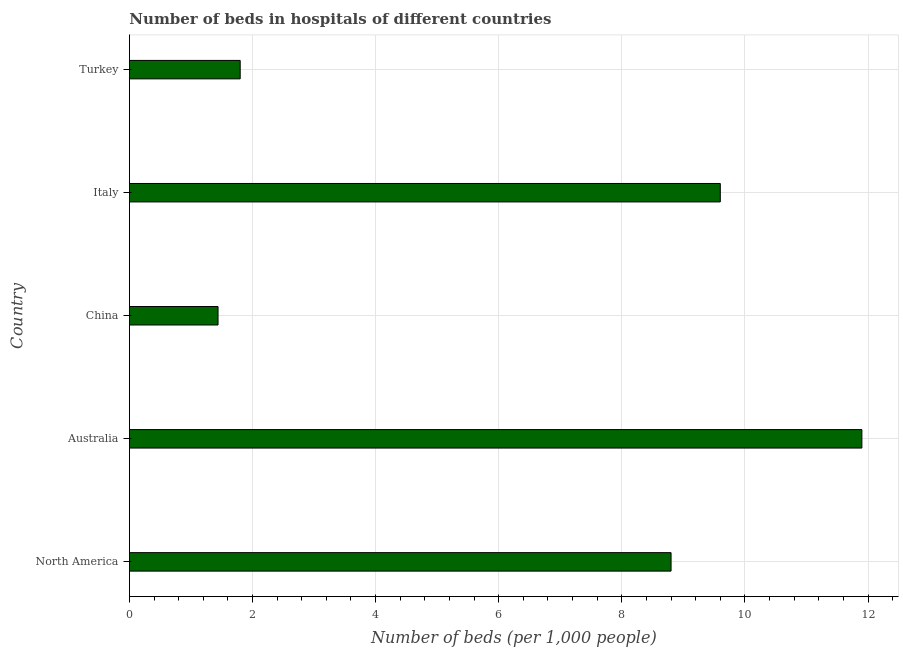Does the graph contain any zero values?
Provide a succinct answer. No. Does the graph contain grids?
Ensure brevity in your answer.  Yes. What is the title of the graph?
Your response must be concise. Number of beds in hospitals of different countries. What is the label or title of the X-axis?
Your answer should be compact. Number of beds (per 1,0 people). What is the number of hospital beds in Australia?
Offer a terse response. 11.9. Across all countries, what is the maximum number of hospital beds?
Offer a terse response. 11.9. Across all countries, what is the minimum number of hospital beds?
Ensure brevity in your answer.  1.44. What is the sum of the number of hospital beds?
Your response must be concise. 33.54. What is the difference between the number of hospital beds in China and North America?
Provide a succinct answer. -7.36. What is the average number of hospital beds per country?
Provide a short and direct response. 6.71. What is the median number of hospital beds?
Ensure brevity in your answer.  8.8. In how many countries, is the number of hospital beds greater than 6 %?
Give a very brief answer. 3. What is the ratio of the number of hospital beds in Italy to that in North America?
Keep it short and to the point. 1.09. Is the number of hospital beds in Italy less than that in Turkey?
Make the answer very short. No. What is the difference between the highest and the second highest number of hospital beds?
Ensure brevity in your answer.  2.3. What is the difference between the highest and the lowest number of hospital beds?
Your answer should be compact. 10.46. Are all the bars in the graph horizontal?
Your answer should be very brief. Yes. What is the difference between two consecutive major ticks on the X-axis?
Your response must be concise. 2. Are the values on the major ticks of X-axis written in scientific E-notation?
Offer a very short reply. No. What is the Number of beds (per 1,000 people) of North America?
Offer a very short reply. 8.8. What is the Number of beds (per 1,000 people) in Australia?
Give a very brief answer. 11.9. What is the Number of beds (per 1,000 people) of China?
Provide a short and direct response. 1.44. What is the Number of beds (per 1,000 people) in Italy?
Provide a succinct answer. 9.6. What is the Number of beds (per 1,000 people) of Turkey?
Provide a succinct answer. 1.8. What is the difference between the Number of beds (per 1,000 people) in North America and Australia?
Make the answer very short. -3.1. What is the difference between the Number of beds (per 1,000 people) in North America and China?
Ensure brevity in your answer.  7.36. What is the difference between the Number of beds (per 1,000 people) in Australia and China?
Ensure brevity in your answer.  10.46. What is the difference between the Number of beds (per 1,000 people) in China and Italy?
Provide a succinct answer. -8.16. What is the difference between the Number of beds (per 1,000 people) in China and Turkey?
Your answer should be compact. -0.36. What is the ratio of the Number of beds (per 1,000 people) in North America to that in Australia?
Make the answer very short. 0.74. What is the ratio of the Number of beds (per 1,000 people) in North America to that in China?
Provide a short and direct response. 6.11. What is the ratio of the Number of beds (per 1,000 people) in North America to that in Italy?
Provide a succinct answer. 0.92. What is the ratio of the Number of beds (per 1,000 people) in North America to that in Turkey?
Ensure brevity in your answer.  4.89. What is the ratio of the Number of beds (per 1,000 people) in Australia to that in China?
Your answer should be very brief. 8.26. What is the ratio of the Number of beds (per 1,000 people) in Australia to that in Italy?
Make the answer very short. 1.24. What is the ratio of the Number of beds (per 1,000 people) in Australia to that in Turkey?
Provide a short and direct response. 6.61. What is the ratio of the Number of beds (per 1,000 people) in China to that in Italy?
Provide a short and direct response. 0.15. What is the ratio of the Number of beds (per 1,000 people) in China to that in Turkey?
Offer a terse response. 0.8. What is the ratio of the Number of beds (per 1,000 people) in Italy to that in Turkey?
Ensure brevity in your answer.  5.33. 